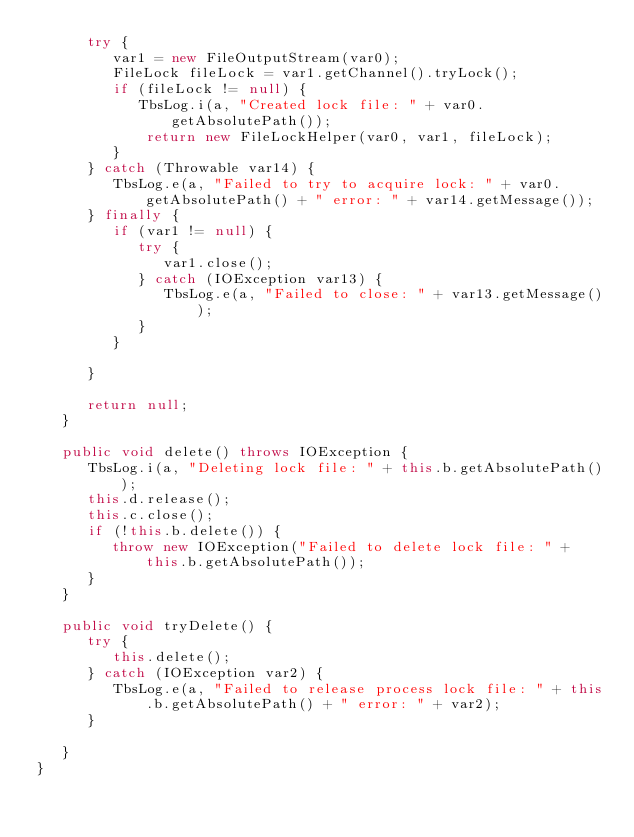<code> <loc_0><loc_0><loc_500><loc_500><_Java_>      try {
         var1 = new FileOutputStream(var0);
         FileLock fileLock = var1.getChannel().tryLock();
         if (fileLock != null) {
            TbsLog.i(a, "Created lock file: " + var0.getAbsolutePath());
			 return new FileLockHelper(var0, var1, fileLock);
         }
      } catch (Throwable var14) {
         TbsLog.e(a, "Failed to try to acquire lock: " + var0.getAbsolutePath() + " error: " + var14.getMessage());
      } finally {
         if (var1 != null) {
            try {
               var1.close();
            } catch (IOException var13) {
               TbsLog.e(a, "Failed to close: " + var13.getMessage());
            }
         }

      }

      return null;
   }

   public void delete() throws IOException {
      TbsLog.i(a, "Deleting lock file: " + this.b.getAbsolutePath());
      this.d.release();
      this.c.close();
      if (!this.b.delete()) {
         throw new IOException("Failed to delete lock file: " + this.b.getAbsolutePath());
      }
   }

   public void tryDelete() {
      try {
         this.delete();
      } catch (IOException var2) {
         TbsLog.e(a, "Failed to release process lock file: " + this.b.getAbsolutePath() + " error: " + var2);
      }

   }
}
</code> 